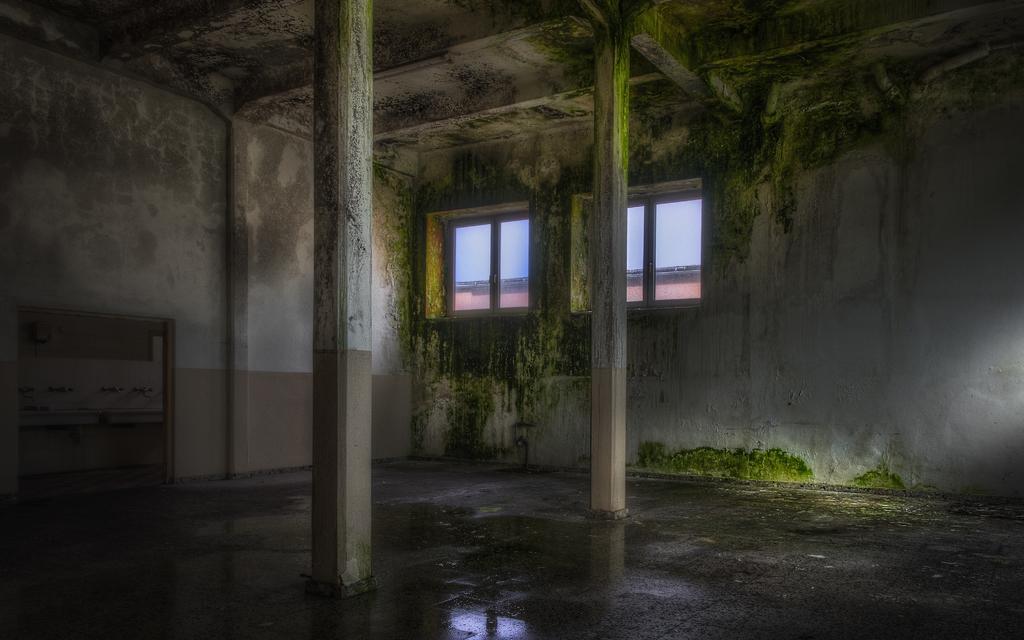Please provide a concise description of this image. This picture describes about inside view of a room, in this we can find few taps. 